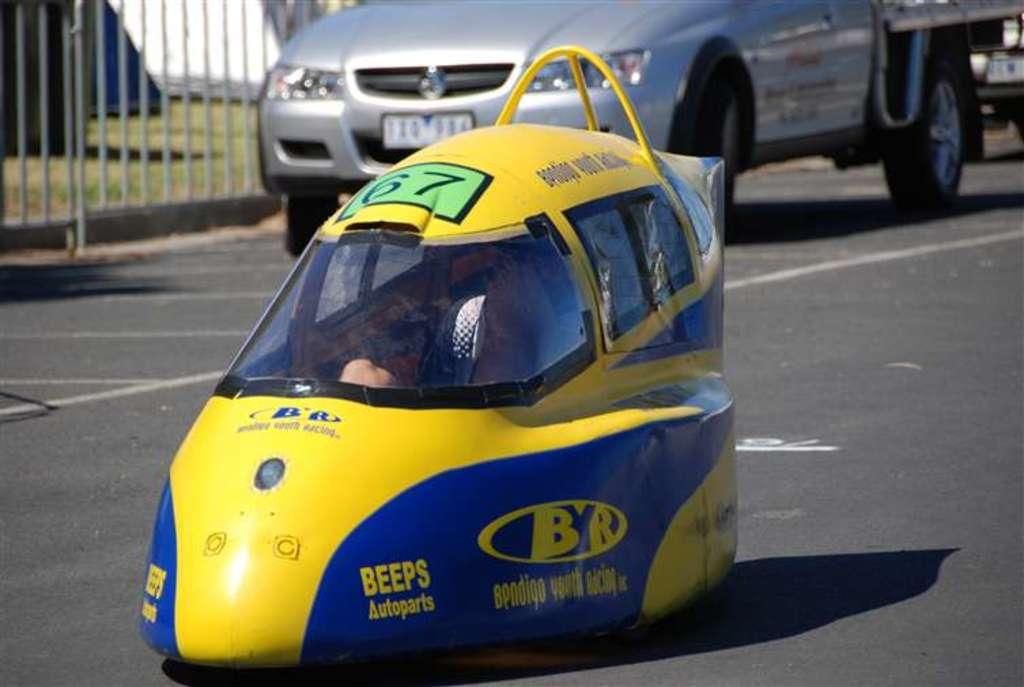What kind of company is beeps?
Provide a short and direct response. Autoparts. Is this race car sponsored by beeps?
Provide a short and direct response. Yes. 